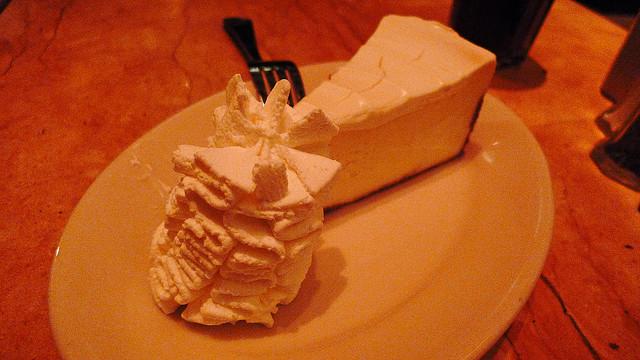Is this from cheesecake factory?
Be succinct. Yes. What shape is the plate?
Quick response, please. Oval. Is this a healthy dessert?
Short answer required. No. How many kinds of food?
Short answer required. 2. 